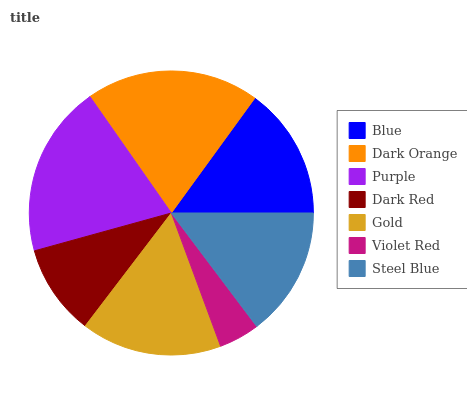Is Violet Red the minimum?
Answer yes or no. Yes. Is Dark Orange the maximum?
Answer yes or no. Yes. Is Purple the minimum?
Answer yes or no. No. Is Purple the maximum?
Answer yes or no. No. Is Dark Orange greater than Purple?
Answer yes or no. Yes. Is Purple less than Dark Orange?
Answer yes or no. Yes. Is Purple greater than Dark Orange?
Answer yes or no. No. Is Dark Orange less than Purple?
Answer yes or no. No. Is Blue the high median?
Answer yes or no. Yes. Is Blue the low median?
Answer yes or no. Yes. Is Gold the high median?
Answer yes or no. No. Is Dark Red the low median?
Answer yes or no. No. 